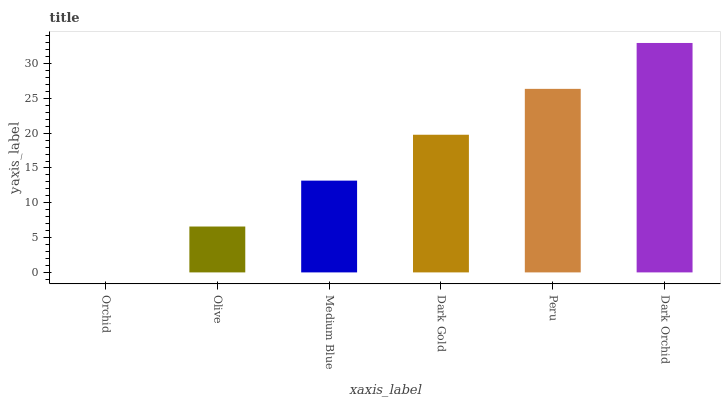Is Orchid the minimum?
Answer yes or no. Yes. Is Dark Orchid the maximum?
Answer yes or no. Yes. Is Olive the minimum?
Answer yes or no. No. Is Olive the maximum?
Answer yes or no. No. Is Olive greater than Orchid?
Answer yes or no. Yes. Is Orchid less than Olive?
Answer yes or no. Yes. Is Orchid greater than Olive?
Answer yes or no. No. Is Olive less than Orchid?
Answer yes or no. No. Is Dark Gold the high median?
Answer yes or no. Yes. Is Medium Blue the low median?
Answer yes or no. Yes. Is Olive the high median?
Answer yes or no. No. Is Dark Orchid the low median?
Answer yes or no. No. 